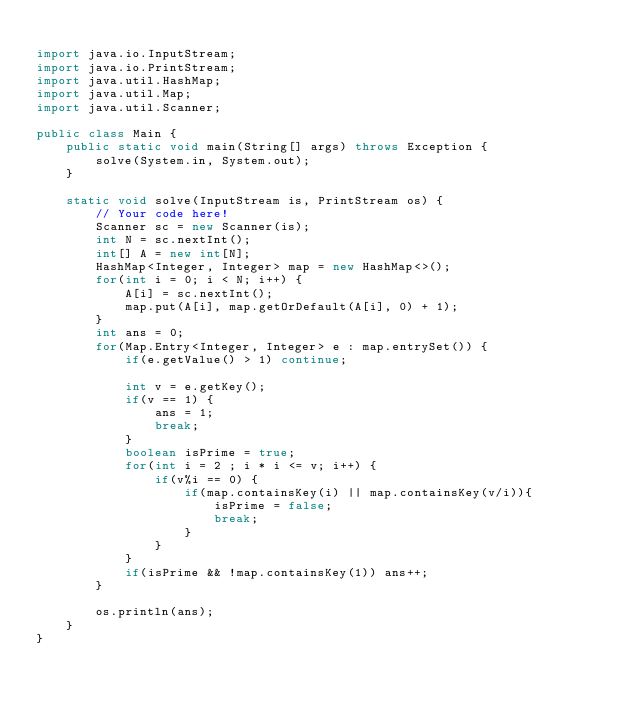<code> <loc_0><loc_0><loc_500><loc_500><_Java_>
import java.io.InputStream;
import java.io.PrintStream;
import java.util.HashMap;
import java.util.Map;
import java.util.Scanner;

public class Main {
    public static void main(String[] args) throws Exception {
        solve(System.in, System.out);
    }

    static void solve(InputStream is, PrintStream os) {
        // Your code here!
        Scanner sc = new Scanner(is);
        int N = sc.nextInt();
        int[] A = new int[N];
        HashMap<Integer, Integer> map = new HashMap<>();
        for(int i = 0; i < N; i++) {
            A[i] = sc.nextInt();
            map.put(A[i], map.getOrDefault(A[i], 0) + 1);
        }
        int ans = 0;
        for(Map.Entry<Integer, Integer> e : map.entrySet()) {
            if(e.getValue() > 1) continue;

            int v = e.getKey();
            if(v == 1) {
                ans = 1;
                break;
            }
            boolean isPrime = true;
            for(int i = 2 ; i * i <= v; i++) {
                if(v%i == 0) {
                    if(map.containsKey(i) || map.containsKey(v/i)){
                        isPrime = false;
                        break;
                    }
                }
            }
            if(isPrime && !map.containsKey(1)) ans++;
        }

        os.println(ans);
    }
}</code> 